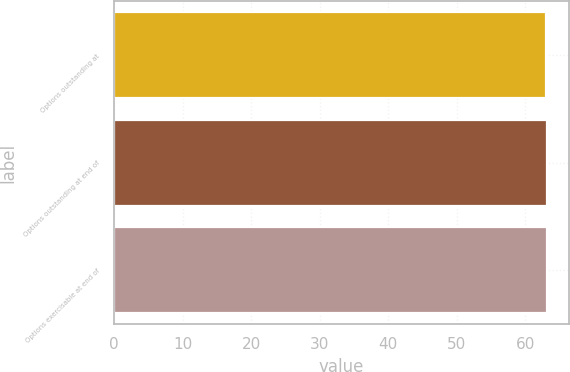<chart> <loc_0><loc_0><loc_500><loc_500><bar_chart><fcel>Options outstanding at<fcel>Options outstanding at end of<fcel>Options exercisable at end of<nl><fcel>63<fcel>63.1<fcel>63.2<nl></chart> 